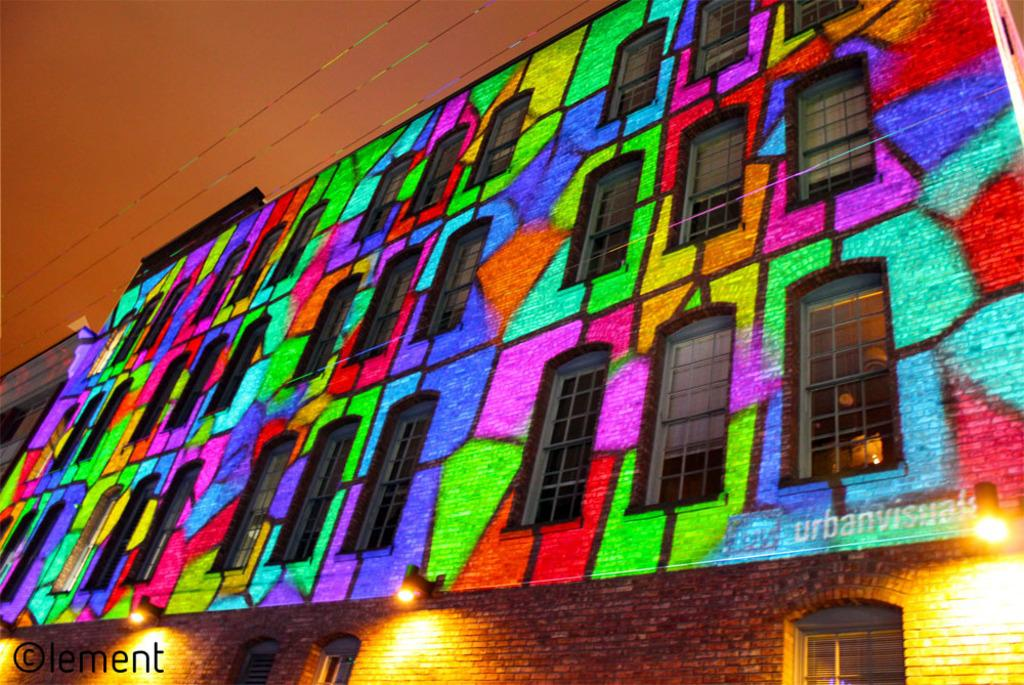What structure is the main subject of the image? There is a building in the image. What can be seen illuminated in the image? There are lights visible in the image. What architectural feature is present in the building? There are windows in the building. What is located on the left side of the image? There is some text on the left side of the image. What is visible in the background of the image? The sky is visible in the background of the image. What type of horn is being played by the person in the image? There is no person or horn present in the image; it features a building with lights, windows, and text. What is the engine used for in the image? There is no engine present in the image; it features a building with lights, windows, and text. 